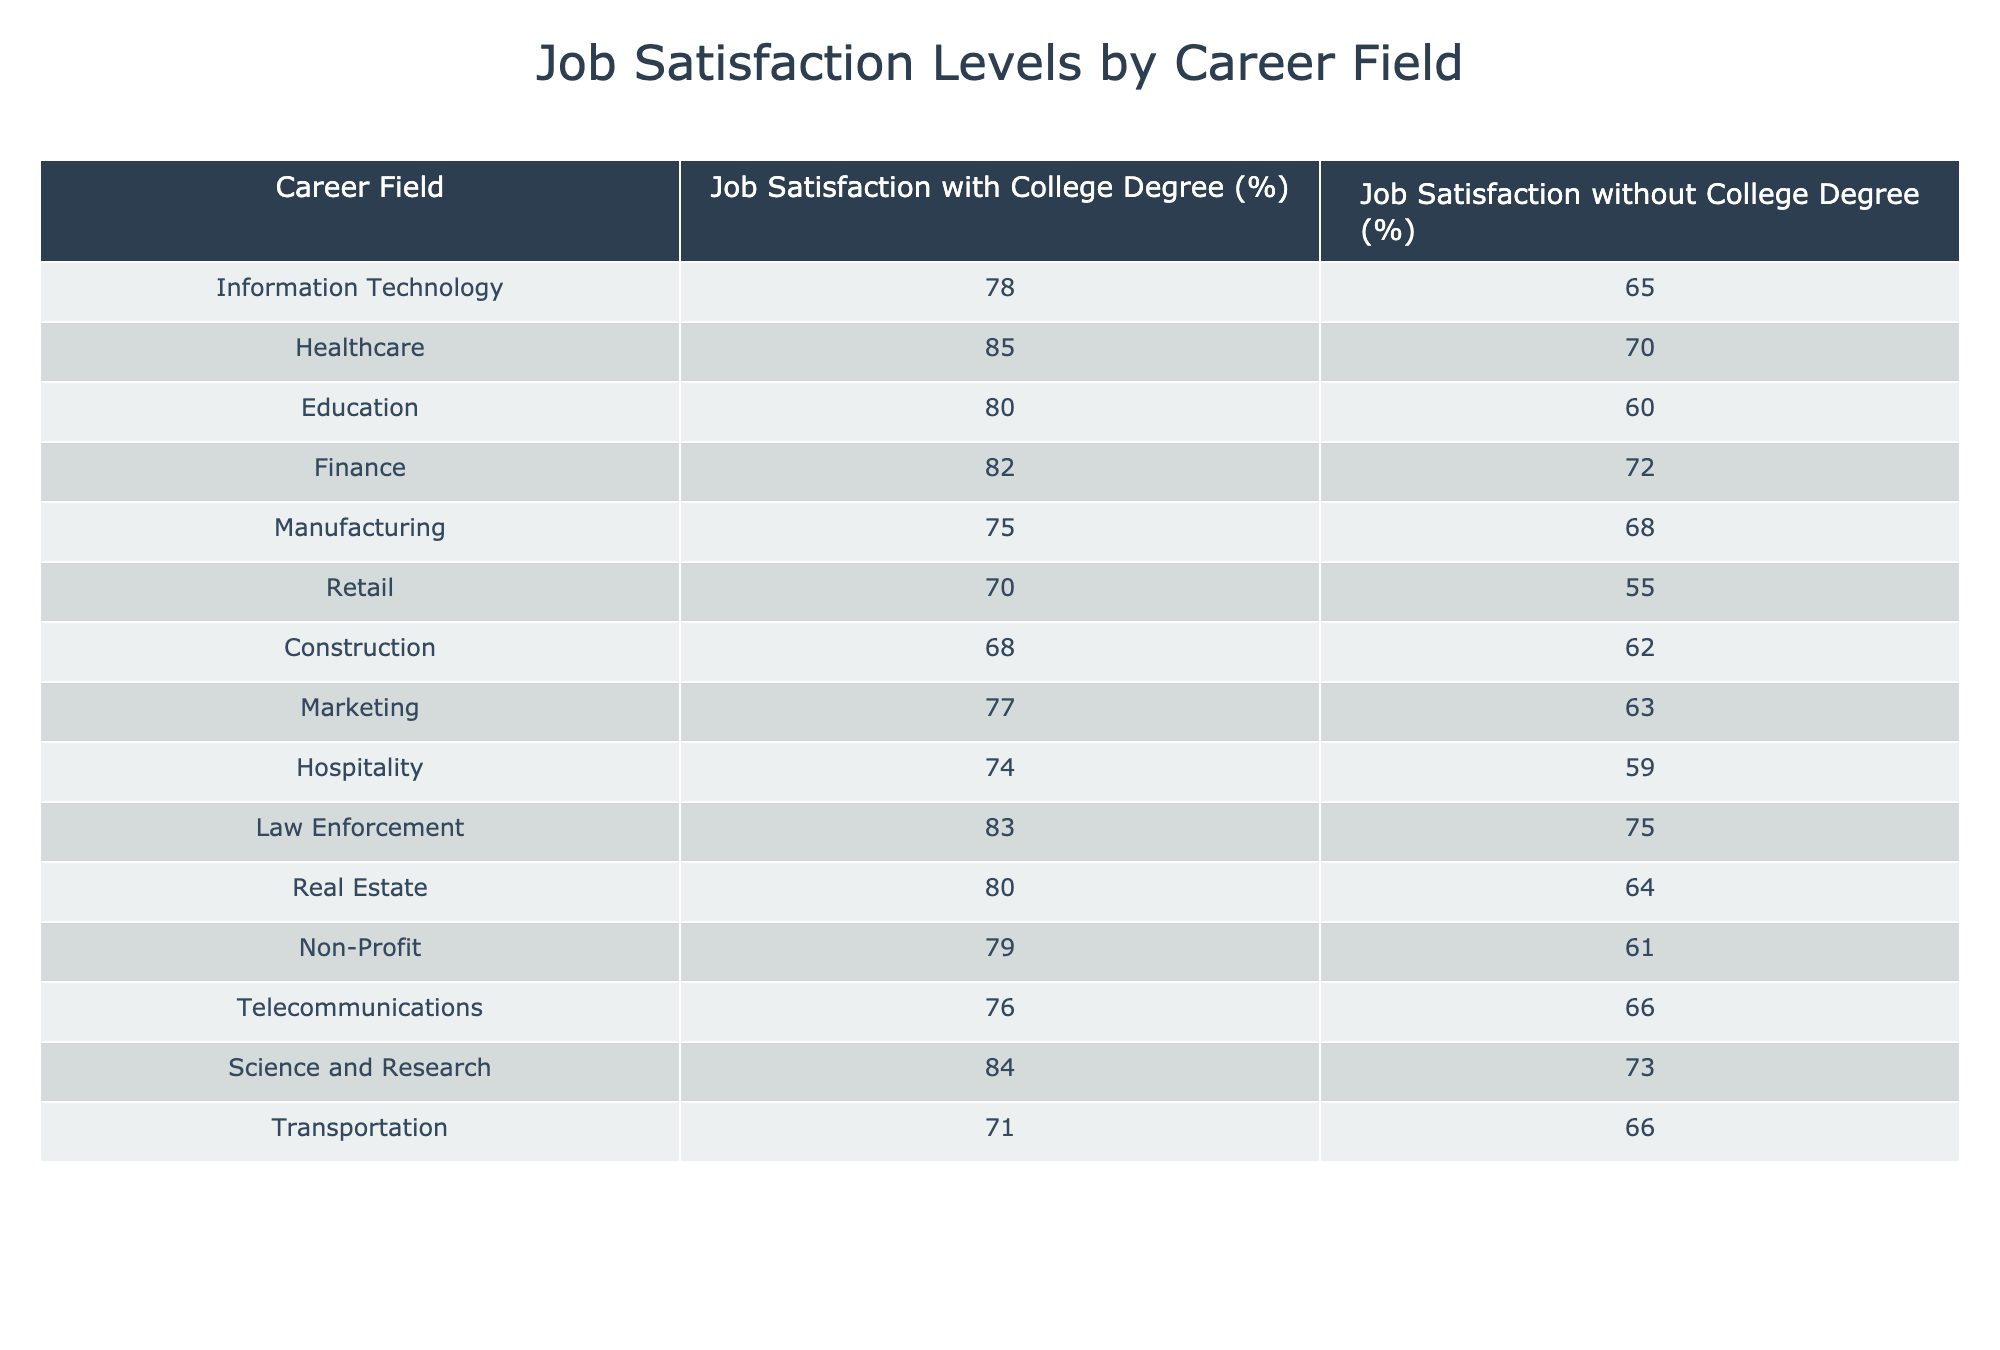What is the job satisfaction level for employees in the healthcare field with a college degree? Referring to the table, the job satisfaction level for employees in the healthcare field with a college degree is 85%.
Answer: 85% What is the job satisfaction percentage difference between employees with and without a college degree in manufacturing? For manufacturing, the job satisfaction level with a college degree is 75%, and without is 68%. The difference is 75% - 68% = 7%.
Answer: 7% Is the job satisfaction level for employees without a college degree in education greater than those in retail? The job satisfaction level for education without a degree is 60%, and for retail, it is 55%. Since 60% is greater than 55%, the statement is true.
Answer: Yes Which career field has the highest job satisfaction level for employees with a college degree? Looking at the table, the highest job satisfaction level for employees with a college degree is in healthcare at 85%.
Answer: Healthcare What is the average job satisfaction level for employees without a college degree across all career fields listed? To find the average, sum the satisfaction levels for employees without a degree: (65 + 70 + 60 + 72 + 68 + 55 + 62 + 63 + 59 + 75 + 64 + 61 + 66 + 73 + 66) = 1005. There are 15 career fields, so the average is 1005/15 = 67%.
Answer: 67% In which career field do employees with a college degree have a job satisfaction level of less than 70%? Checking the table, only the manufacturing field (75%) and retail field (70%) have job satisfaction levels under 70%. Therefore, there are none as both are 70% or more for the degree holders.
Answer: None What is the job satisfaction level for employees in law enforcement without a college degree compared to those in hospitality with a college degree? In law enforcement, the job satisfaction level without a degree is 75%, and in hospitality with a degree is 74%. Comparing these values, 75% (law enforcement) is greater than 74% (hospitality).
Answer: Greater Which career field shows the smallest gap in job satisfaction levels between employees with and without a college degree? By examining the differences: (78-65=13, 85-70=15, 80-60=20, etc.), the smallest gap of 5% occurs in construction (68% vs 62%).
Answer: Construction What is the job satisfaction level for employees in the real estate field with a college degree? The table shows that the job satisfaction level for employees in the real estate field with a college degree is 80%.
Answer: 80% Are employees in telecommunications with a college degree more satisfied than those in manufacturing without a degree? Telecommunications has a college degree satisfaction rate of 76%, whereas manufacturing without a degree is 68%. Since 76% is greater than 68%, the answer is yes.
Answer: Yes How many career fields listed have job satisfaction percentages higher than 80% for employees with college degrees? The career fields with over 80% satisfaction for college graduates are healthcare (85%), law enforcement (83%), finance (82%), and science and research (84%). This is a total of 4 fields.
Answer: 4 